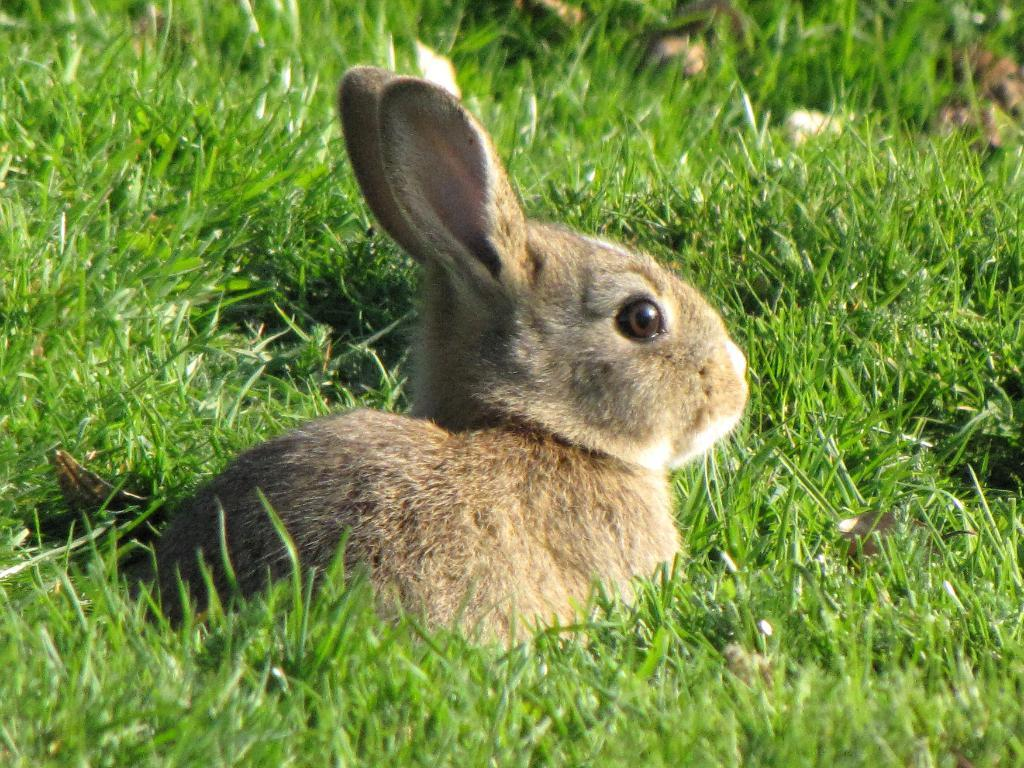What animal is present in the image? There is a rabbit in the image. Where is the rabbit located? The rabbit is on the grass. What type of car is visible in the image? There is no car present in the image; it features a rabbit on the grass. What shape is the rabbit's head in the image? The image does not provide enough detail to determine the shape of the rabbit's head. 